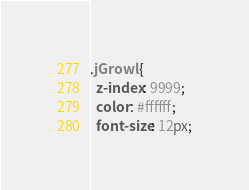Convert code to text. <code><loc_0><loc_0><loc_500><loc_500><_CSS_>.jGrowl {
  z-index: 9999;
  color: #ffffff;
  font-size: 12px;</code> 